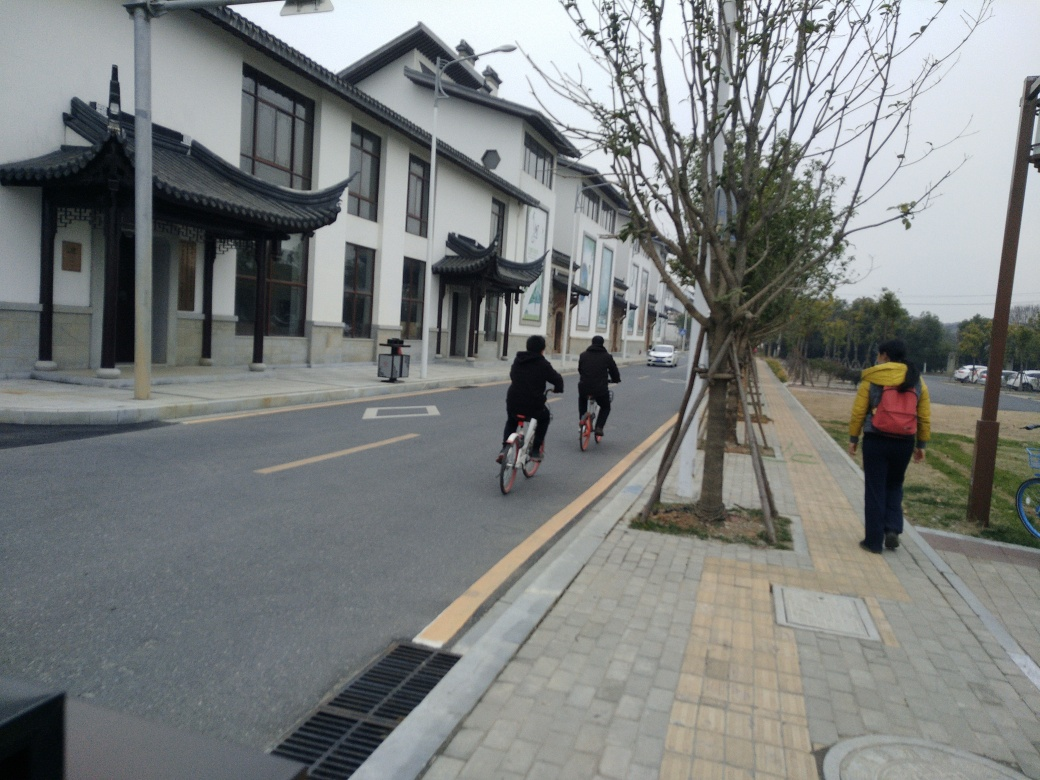What is the lighting like in the photo? The lighting in the photo appears to be relatively flat and overcast, with no harsh shadows or bright highlights indicating a bright sunny day. It creates a soft and even light distribution but may lead one to describe it as slightly dim due to the lack of strong sunlight. The overall ambience can be described as subdued and calm. 